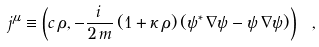<formula> <loc_0><loc_0><loc_500><loc_500>j ^ { \mu } \equiv \left ( c \, \rho , - \frac { i \, } { 2 \, m } \, ( 1 + \kappa \, \rho ) \, ( \psi ^ { \ast } \, { \nabla } \psi - \psi \, { \nabla } \psi ) \right ) \ ,</formula> 